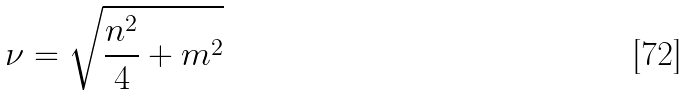Convert formula to latex. <formula><loc_0><loc_0><loc_500><loc_500>\nu = \sqrt { \frac { n ^ { 2 } } { 4 } + m ^ { 2 } }</formula> 